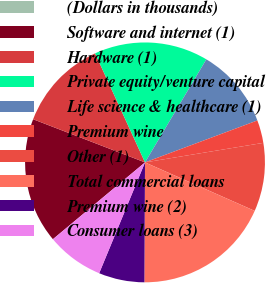<chart> <loc_0><loc_0><loc_500><loc_500><pie_chart><fcel>(Dollars in thousands)<fcel>Software and internet (1)<fcel>Hardware (1)<fcel>Private equity/venture capital<fcel>Life science & healthcare (1)<fcel>Premium wine<fcel>Other (1)<fcel>Total commercial loans<fcel>Premium wine (2)<fcel>Consumer loans (3)<nl><fcel>0.01%<fcel>16.92%<fcel>12.31%<fcel>15.38%<fcel>10.77%<fcel>3.08%<fcel>9.23%<fcel>18.46%<fcel>6.16%<fcel>7.69%<nl></chart> 